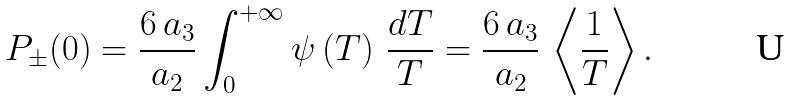Convert formula to latex. <formula><loc_0><loc_0><loc_500><loc_500>P _ { \pm } ( 0 ) = \frac { 6 \, a _ { 3 } } { a _ { 2 } } \int _ { 0 } ^ { + \infty } \psi \left ( T \right ) \, \frac { d T } { T } = \frac { 6 \, a _ { 3 } } { a _ { 2 } } \, \left \langle \frac { 1 } { T } \right \rangle .</formula> 